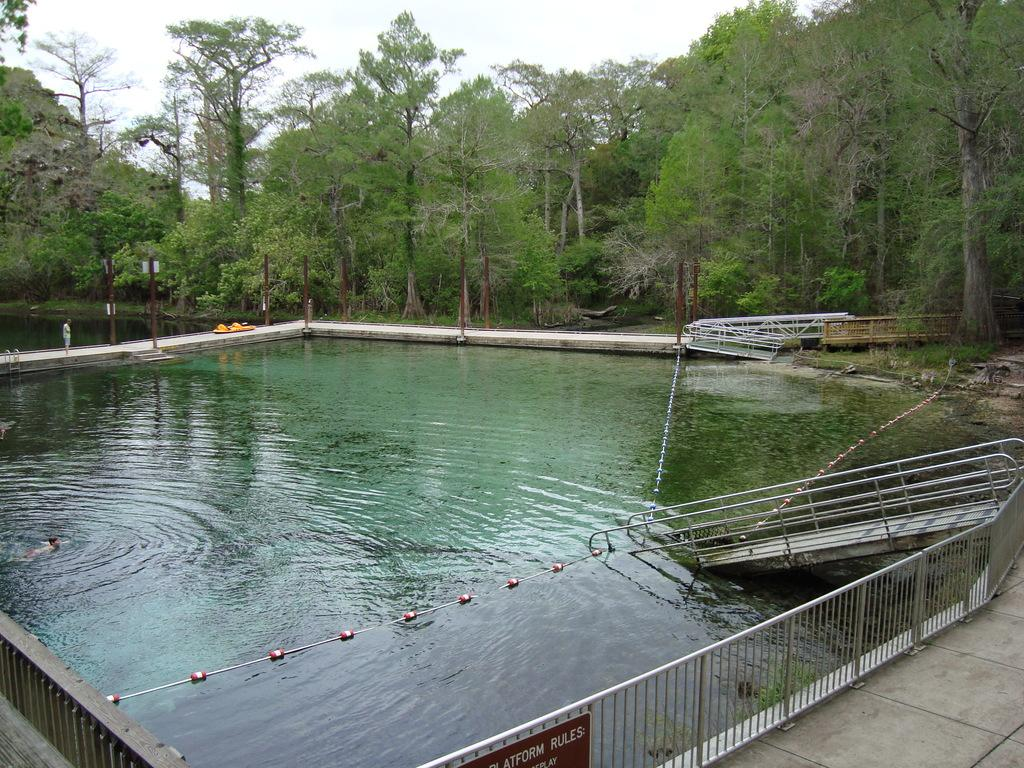What is in the water in the image? There are objects in the water in the image. What is attached to the fence in the image? There is a board on a fence in the image. What can be used for support or guidance in the image? Railings are present in the image. What is on the platform in the image? There are objects on a platform in the image. What is attached to poles in the image? There are boards on poles in the image. What type of vegetation is visible in the image? Trees are visible in the image. What part of the natural environment is visible in the image? The sky is visible in the image. What type of hair can be seen on the objects in the water? There is no hair present on the objects in the water; they are inanimate objects. What type of ray is visible in the image? There is no ray visible in the image. 